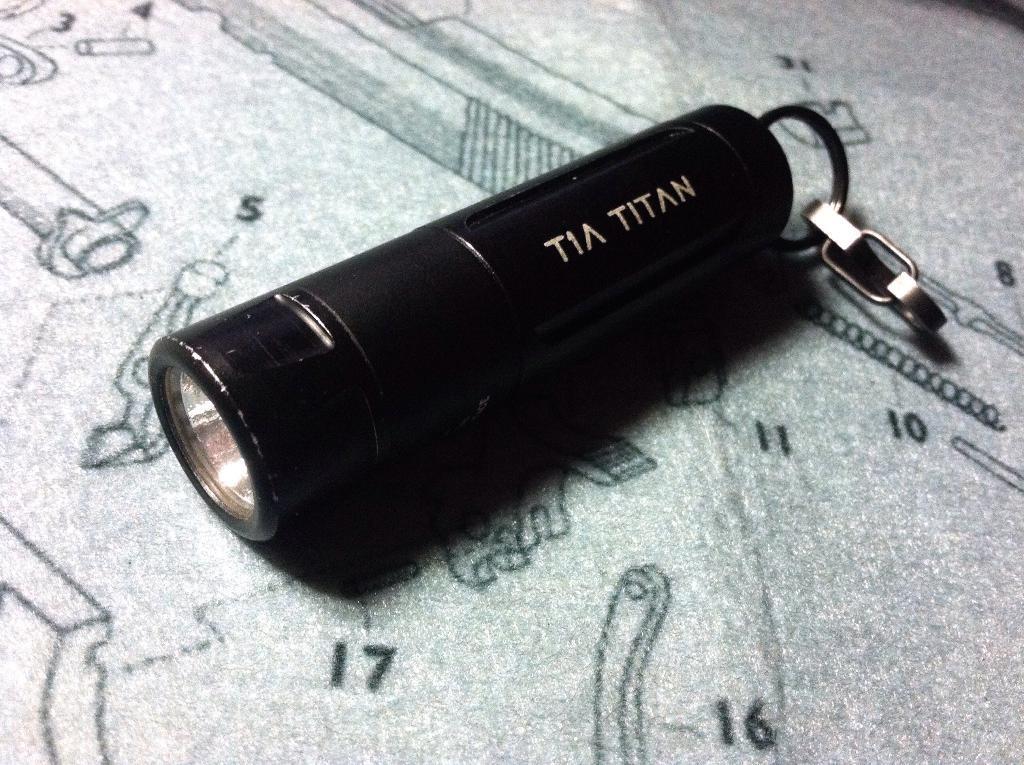Please provide a concise description of this image. In this image we can see a torch light. In the background we can see some numbers on the surface. 